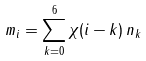<formula> <loc_0><loc_0><loc_500><loc_500>m _ { i } = \sum _ { k = 0 } ^ { 6 } \chi ( i - k ) \, n _ { k }</formula> 